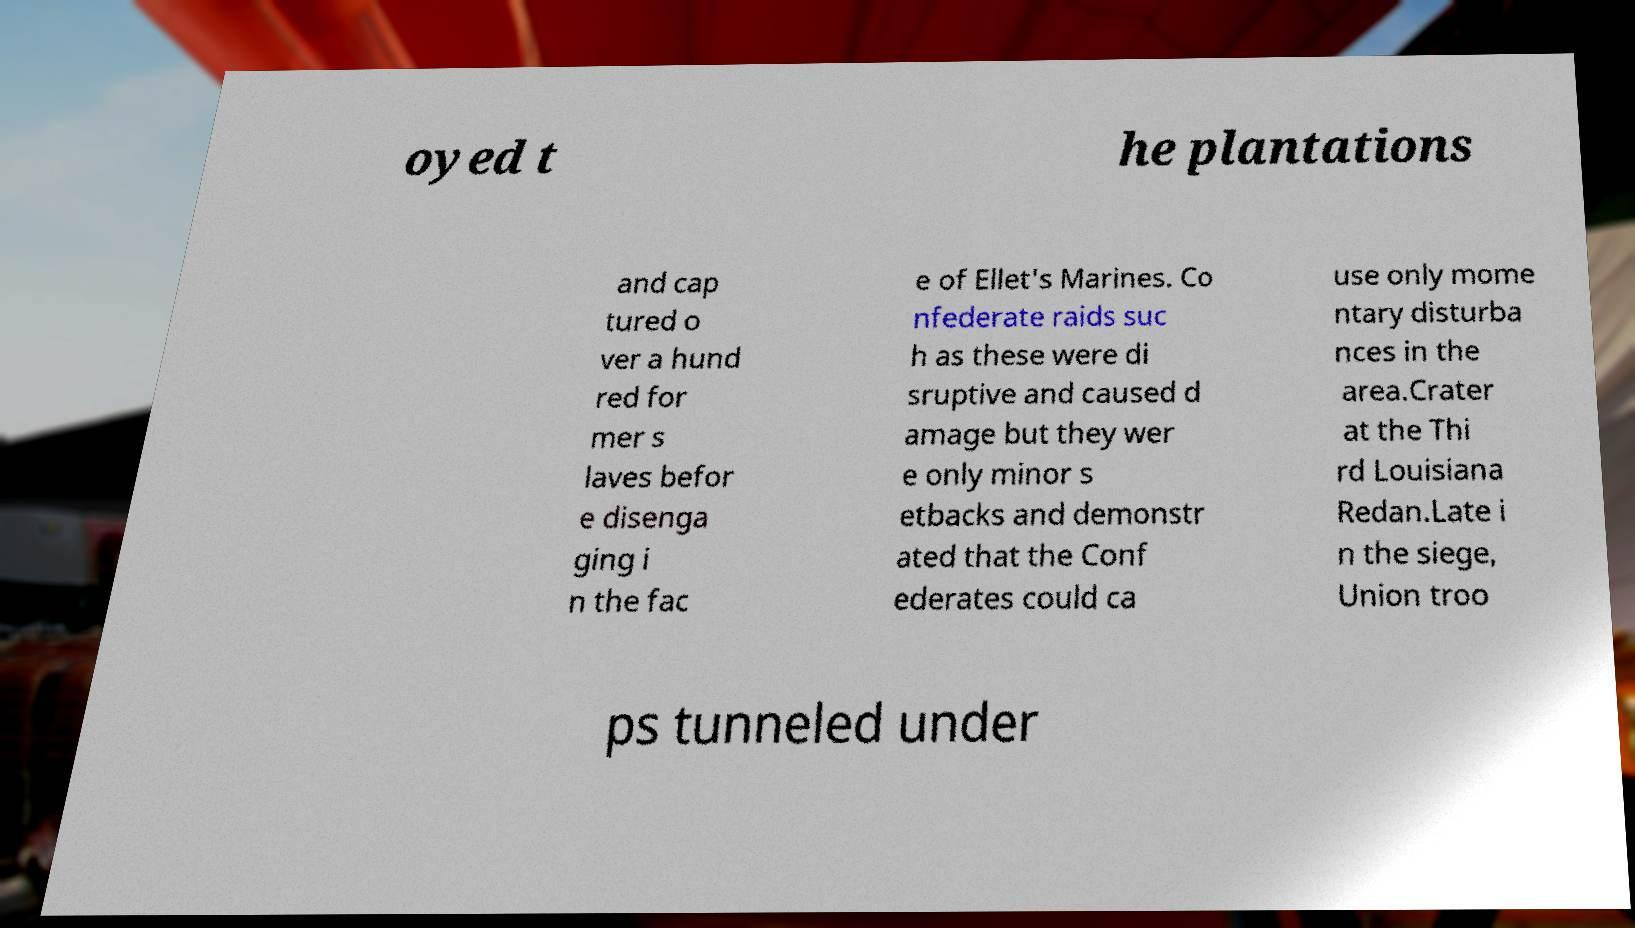Could you assist in decoding the text presented in this image and type it out clearly? oyed t he plantations and cap tured o ver a hund red for mer s laves befor e disenga ging i n the fac e of Ellet's Marines. Co nfederate raids suc h as these were di sruptive and caused d amage but they wer e only minor s etbacks and demonstr ated that the Conf ederates could ca use only mome ntary disturba nces in the area.Crater at the Thi rd Louisiana Redan.Late i n the siege, Union troo ps tunneled under 